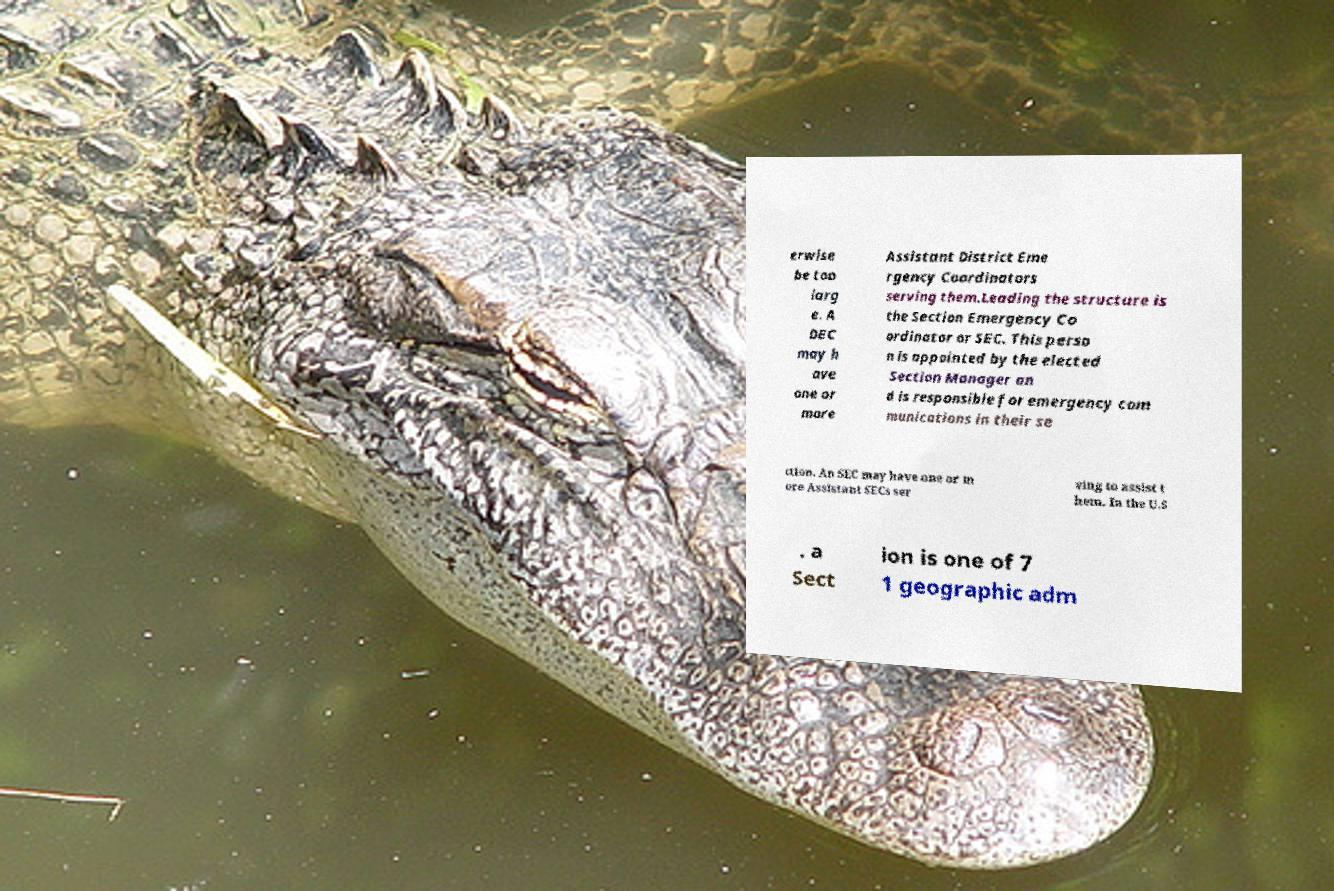There's text embedded in this image that I need extracted. Can you transcribe it verbatim? erwise be too larg e. A DEC may h ave one or more Assistant District Eme rgency Coordinators serving them.Leading the structure is the Section Emergency Co ordinator or SEC. This perso n is appointed by the elected Section Manager an d is responsible for emergency com munications in their se ction. An SEC may have one or m ore Assistant SECs ser ving to assist t hem. In the U.S . a Sect ion is one of 7 1 geographic adm 